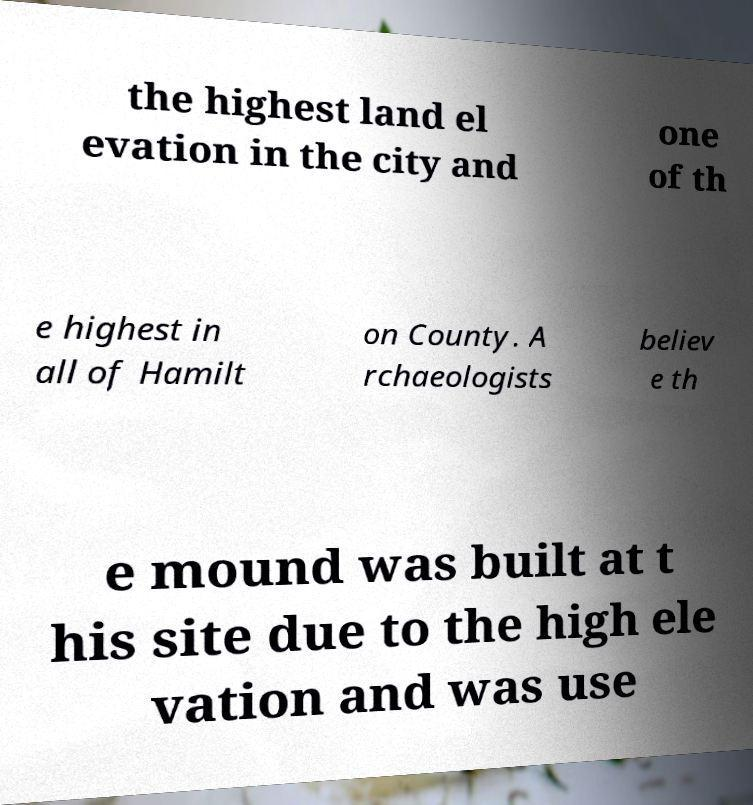Please read and relay the text visible in this image. What does it say? the highest land el evation in the city and one of th e highest in all of Hamilt on County. A rchaeologists believ e th e mound was built at t his site due to the high ele vation and was use 